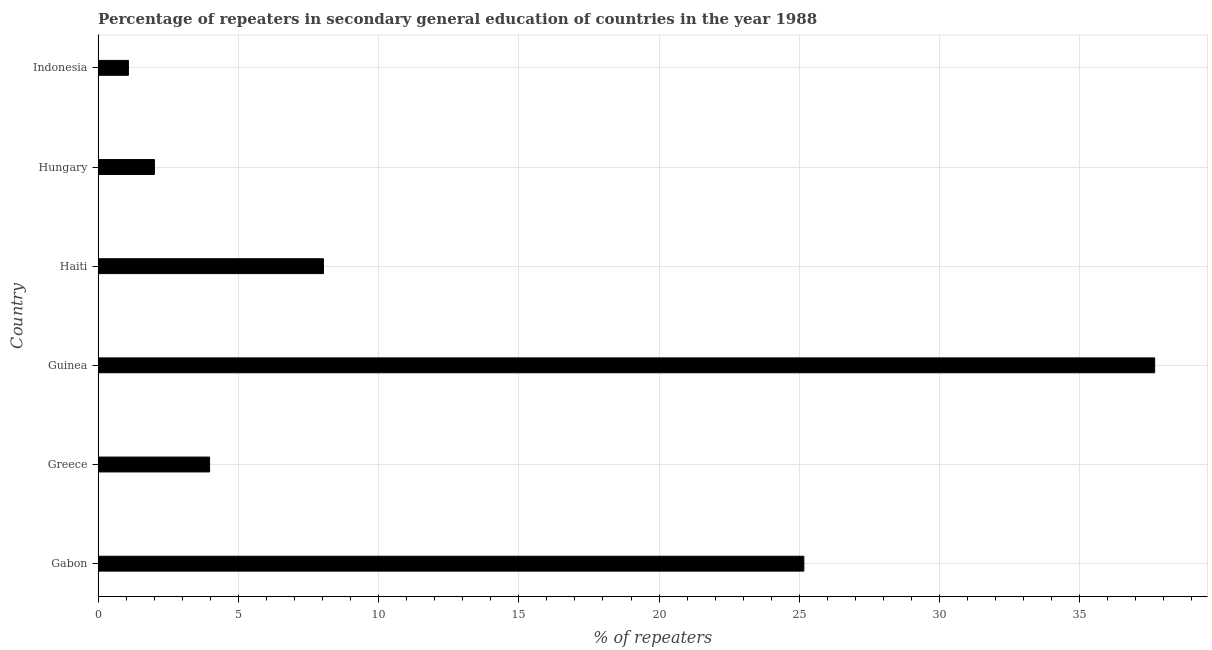What is the title of the graph?
Provide a short and direct response. Percentage of repeaters in secondary general education of countries in the year 1988. What is the label or title of the X-axis?
Keep it short and to the point. % of repeaters. What is the label or title of the Y-axis?
Your response must be concise. Country. What is the percentage of repeaters in Haiti?
Ensure brevity in your answer.  8.03. Across all countries, what is the maximum percentage of repeaters?
Your response must be concise. 37.67. Across all countries, what is the minimum percentage of repeaters?
Provide a succinct answer. 1.08. In which country was the percentage of repeaters maximum?
Provide a short and direct response. Guinea. In which country was the percentage of repeaters minimum?
Keep it short and to the point. Indonesia. What is the sum of the percentage of repeaters?
Make the answer very short. 77.93. What is the difference between the percentage of repeaters in Gabon and Haiti?
Offer a very short reply. 17.13. What is the average percentage of repeaters per country?
Give a very brief answer. 12.99. What is the median percentage of repeaters?
Offer a very short reply. 6. What is the ratio of the percentage of repeaters in Gabon to that in Haiti?
Provide a succinct answer. 3.13. Is the percentage of repeaters in Gabon less than that in Indonesia?
Ensure brevity in your answer.  No. What is the difference between the highest and the second highest percentage of repeaters?
Your answer should be very brief. 12.51. What is the difference between the highest and the lowest percentage of repeaters?
Your answer should be very brief. 36.59. In how many countries, is the percentage of repeaters greater than the average percentage of repeaters taken over all countries?
Provide a short and direct response. 2. How many bars are there?
Make the answer very short. 6. Are the values on the major ticks of X-axis written in scientific E-notation?
Your answer should be very brief. No. What is the % of repeaters of Gabon?
Offer a very short reply. 25.16. What is the % of repeaters in Greece?
Give a very brief answer. 3.97. What is the % of repeaters of Guinea?
Keep it short and to the point. 37.67. What is the % of repeaters of Haiti?
Your answer should be very brief. 8.03. What is the % of repeaters of Hungary?
Make the answer very short. 2.01. What is the % of repeaters in Indonesia?
Give a very brief answer. 1.08. What is the difference between the % of repeaters in Gabon and Greece?
Ensure brevity in your answer.  21.19. What is the difference between the % of repeaters in Gabon and Guinea?
Provide a short and direct response. -12.51. What is the difference between the % of repeaters in Gabon and Haiti?
Your answer should be compact. 17.13. What is the difference between the % of repeaters in Gabon and Hungary?
Offer a very short reply. 23.16. What is the difference between the % of repeaters in Gabon and Indonesia?
Keep it short and to the point. 24.08. What is the difference between the % of repeaters in Greece and Guinea?
Offer a very short reply. -33.7. What is the difference between the % of repeaters in Greece and Haiti?
Your response must be concise. -4.06. What is the difference between the % of repeaters in Greece and Hungary?
Provide a short and direct response. 1.97. What is the difference between the % of repeaters in Greece and Indonesia?
Ensure brevity in your answer.  2.89. What is the difference between the % of repeaters in Guinea and Haiti?
Offer a very short reply. 29.64. What is the difference between the % of repeaters in Guinea and Hungary?
Provide a short and direct response. 35.66. What is the difference between the % of repeaters in Guinea and Indonesia?
Ensure brevity in your answer.  36.59. What is the difference between the % of repeaters in Haiti and Hungary?
Ensure brevity in your answer.  6.03. What is the difference between the % of repeaters in Haiti and Indonesia?
Your answer should be compact. 6.95. What is the difference between the % of repeaters in Hungary and Indonesia?
Give a very brief answer. 0.93. What is the ratio of the % of repeaters in Gabon to that in Greece?
Your answer should be compact. 6.33. What is the ratio of the % of repeaters in Gabon to that in Guinea?
Your answer should be compact. 0.67. What is the ratio of the % of repeaters in Gabon to that in Haiti?
Provide a succinct answer. 3.13. What is the ratio of the % of repeaters in Gabon to that in Hungary?
Give a very brief answer. 12.54. What is the ratio of the % of repeaters in Gabon to that in Indonesia?
Offer a terse response. 23.29. What is the ratio of the % of repeaters in Greece to that in Guinea?
Give a very brief answer. 0.11. What is the ratio of the % of repeaters in Greece to that in Haiti?
Your answer should be very brief. 0.49. What is the ratio of the % of repeaters in Greece to that in Hungary?
Provide a succinct answer. 1.98. What is the ratio of the % of repeaters in Greece to that in Indonesia?
Make the answer very short. 3.68. What is the ratio of the % of repeaters in Guinea to that in Haiti?
Your answer should be very brief. 4.69. What is the ratio of the % of repeaters in Guinea to that in Hungary?
Offer a very short reply. 18.77. What is the ratio of the % of repeaters in Guinea to that in Indonesia?
Provide a short and direct response. 34.87. What is the ratio of the % of repeaters in Haiti to that in Hungary?
Keep it short and to the point. 4. What is the ratio of the % of repeaters in Haiti to that in Indonesia?
Your answer should be compact. 7.44. What is the ratio of the % of repeaters in Hungary to that in Indonesia?
Give a very brief answer. 1.86. 